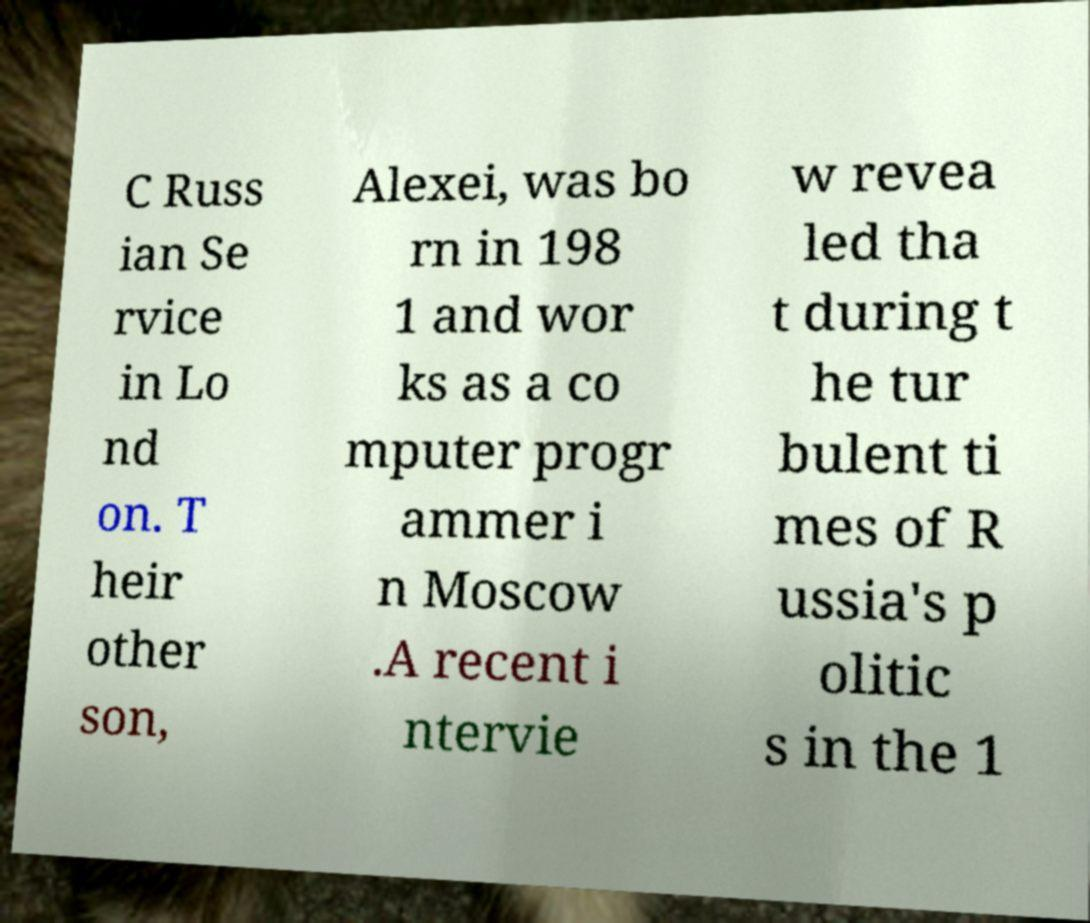For documentation purposes, I need the text within this image transcribed. Could you provide that? C Russ ian Se rvice in Lo nd on. T heir other son, Alexei, was bo rn in 198 1 and wor ks as a co mputer progr ammer i n Moscow .A recent i ntervie w revea led tha t during t he tur bulent ti mes of R ussia's p olitic s in the 1 